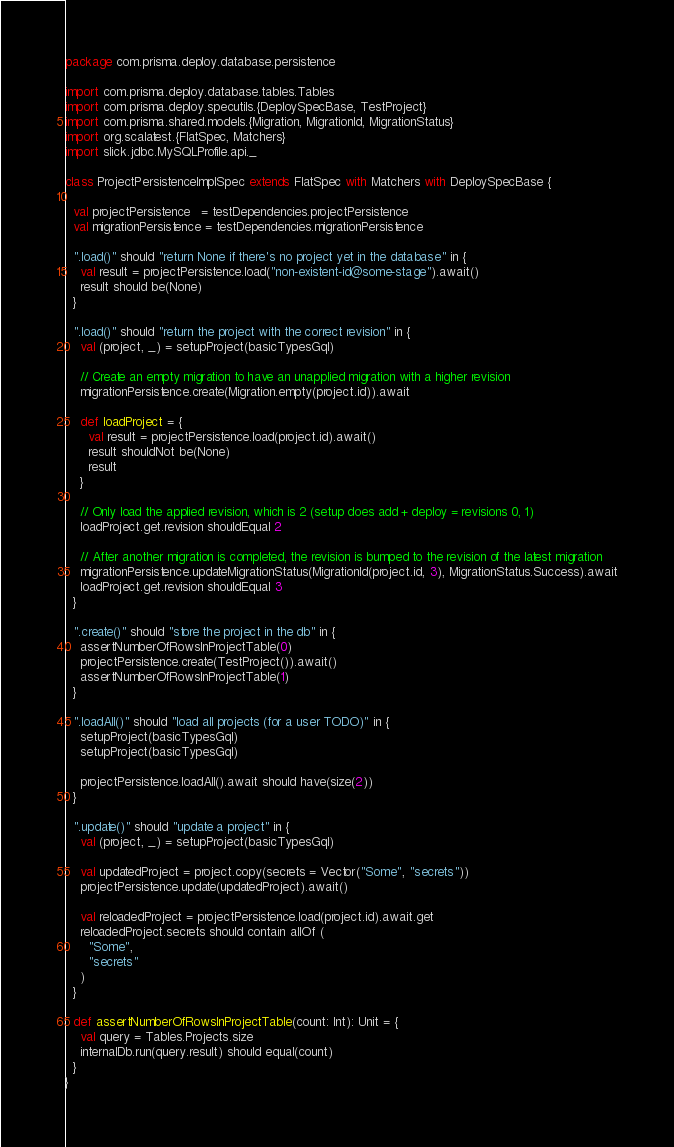Convert code to text. <code><loc_0><loc_0><loc_500><loc_500><_Scala_>package com.prisma.deploy.database.persistence

import com.prisma.deploy.database.tables.Tables
import com.prisma.deploy.specutils.{DeploySpecBase, TestProject}
import com.prisma.shared.models.{Migration, MigrationId, MigrationStatus}
import org.scalatest.{FlatSpec, Matchers}
import slick.jdbc.MySQLProfile.api._

class ProjectPersistenceImplSpec extends FlatSpec with Matchers with DeploySpecBase {

  val projectPersistence   = testDependencies.projectPersistence
  val migrationPersistence = testDependencies.migrationPersistence

  ".load()" should "return None if there's no project yet in the database" in {
    val result = projectPersistence.load("non-existent-id@some-stage").await()
    result should be(None)
  }

  ".load()" should "return the project with the correct revision" in {
    val (project, _) = setupProject(basicTypesGql)

    // Create an empty migration to have an unapplied migration with a higher revision
    migrationPersistence.create(Migration.empty(project.id)).await

    def loadProject = {
      val result = projectPersistence.load(project.id).await()
      result shouldNot be(None)
      result
    }

    // Only load the applied revision, which is 2 (setup does add + deploy = revisions 0, 1)
    loadProject.get.revision shouldEqual 2

    // After another migration is completed, the revision is bumped to the revision of the latest migration
    migrationPersistence.updateMigrationStatus(MigrationId(project.id, 3), MigrationStatus.Success).await
    loadProject.get.revision shouldEqual 3
  }

  ".create()" should "store the project in the db" in {
    assertNumberOfRowsInProjectTable(0)
    projectPersistence.create(TestProject()).await()
    assertNumberOfRowsInProjectTable(1)
  }

  ".loadAll()" should "load all projects (for a user TODO)" in {
    setupProject(basicTypesGql)
    setupProject(basicTypesGql)

    projectPersistence.loadAll().await should have(size(2))
  }

  ".update()" should "update a project" in {
    val (project, _) = setupProject(basicTypesGql)

    val updatedProject = project.copy(secrets = Vector("Some", "secrets"))
    projectPersistence.update(updatedProject).await()

    val reloadedProject = projectPersistence.load(project.id).await.get
    reloadedProject.secrets should contain allOf (
      "Some",
      "secrets"
    )
  }

  def assertNumberOfRowsInProjectTable(count: Int): Unit = {
    val query = Tables.Projects.size
    internalDb.run(query.result) should equal(count)
  }
}
</code> 